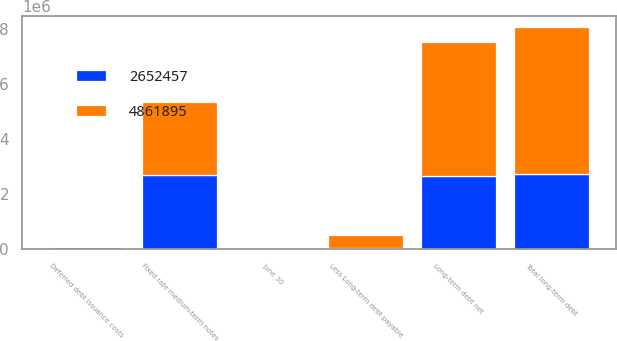<chart> <loc_0><loc_0><loc_500><loc_500><stacked_bar_chart><ecel><fcel>June 30<fcel>Fixed rate medium-term notes<fcel>Deferred debt issuance costs<fcel>Total long-term debt<fcel>Less Long-term debt payable<fcel>Long-term debt net<nl><fcel>4.8619e+06<fcel>2017<fcel>2.675e+06<fcel>47183<fcel>5.33616e+06<fcel>474265<fcel>4.8619e+06<nl><fcel>2.65246e+06<fcel>2016<fcel>2.675e+06<fcel>22596<fcel>2.71054e+06<fcel>58087<fcel>2.65246e+06<nl></chart> 